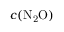Convert formula to latex. <formula><loc_0><loc_0><loc_500><loc_500>c ( N _ { 2 } O )</formula> 